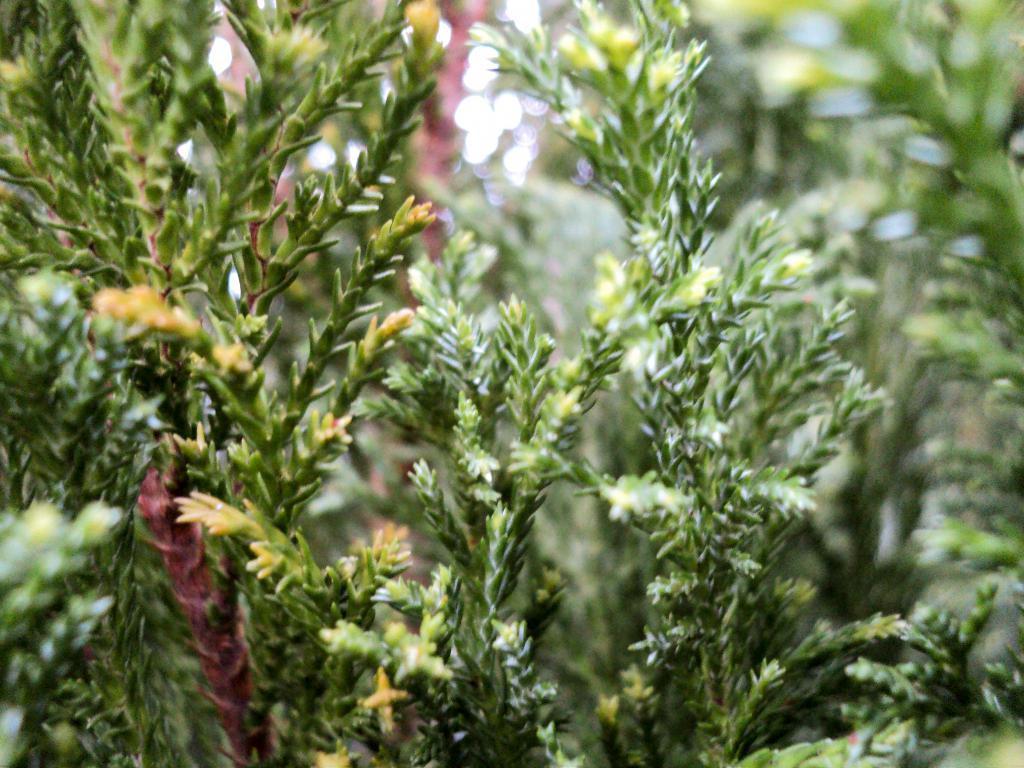In one or two sentences, can you explain what this image depicts? In this image we can see the stems of a plant. 